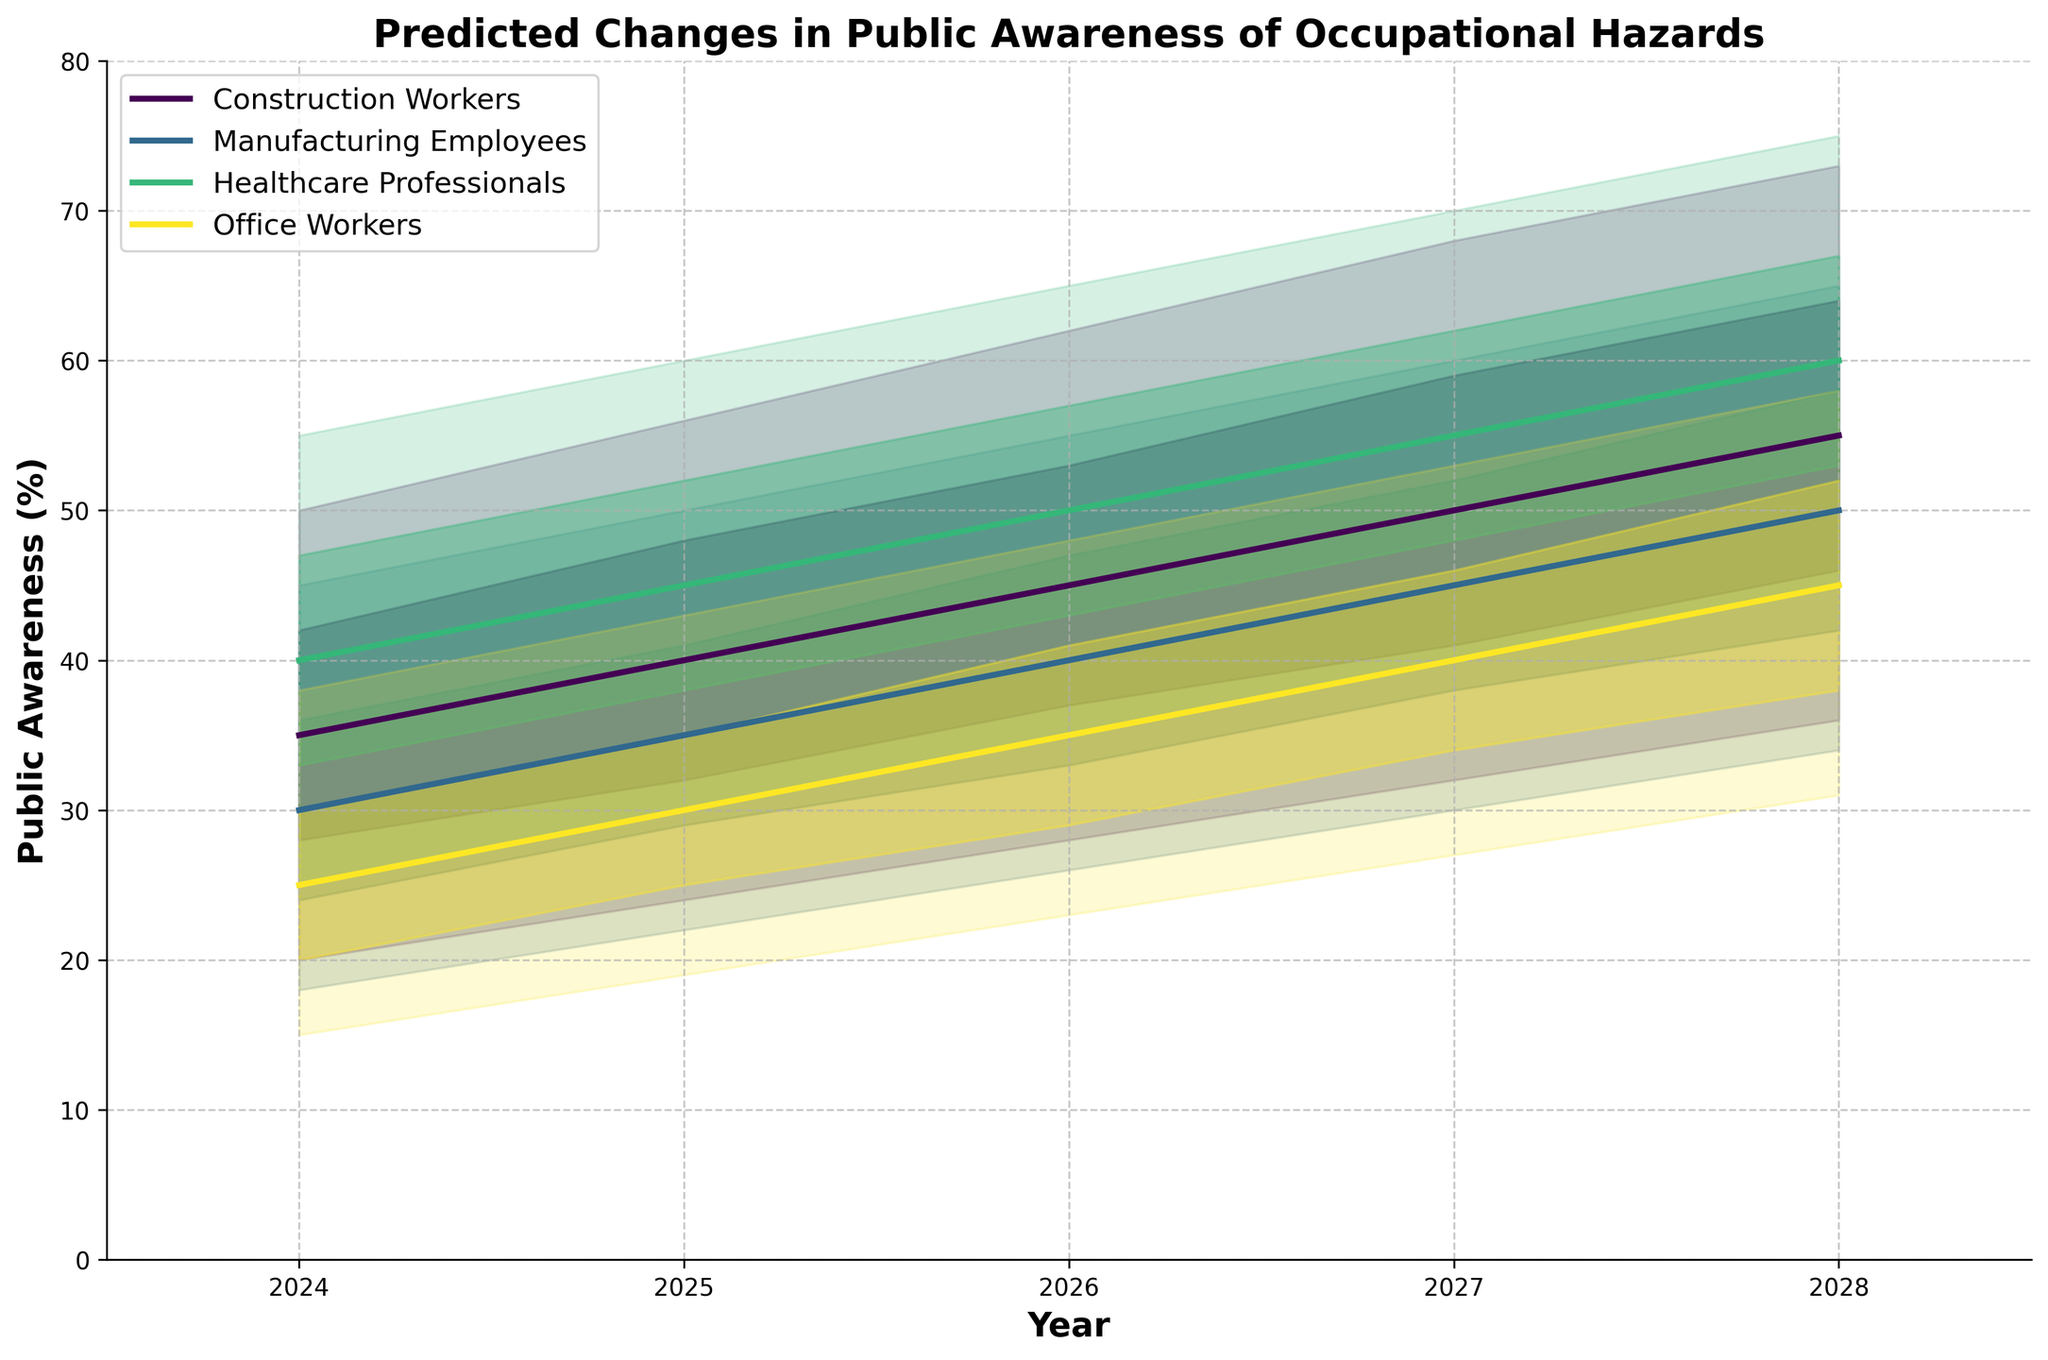What is the title of the chart? The title is located at the top of the chart, it reads "Predicted Changes in Public Awareness of Occupational Hazards."
Answer: Predicted Changes in Public Awareness of Occupational Hazards Which category has the highest median prediction for the year 2028? By checking the median line for each category in the year 2028, the category with the highest value is "Healthcare Professionals" with a median of 60%.
Answer: Healthcare Professionals What is the range for the 'Upper 75%' value for Construction Workers from 2024 to 2028? The 'Upper 75%' values for Construction Workers from 2024 to 2028 are 42, 48, 53, 59, and 64, respectively.
Answer: 42 to 64 How does the median prediction for Office Workers change from 2024 to 2028? The median predictions for Office Workers from 2024 to 2028 are 25%, 30%, 35%, 40%, and 45%, respectively, indicating a steady increase.
Answer: Steady increase Compare the upper 90% prediction for Manufacturing Employees and Healthcare Professionals in 2025. Which is higher and by how much? In 2025, the upper 90% prediction for Manufacturing Employees is 50% while for Healthcare Professionals it is 60%. The difference is 10%.
Answer: Healthcare Professionals by 10% What's the lower 10% value for Office Workers in 2026? The lower 10% value is found at the bottom edge of the lightest shaded region for Office Workers in 2026, which is 23%.
Answer: 23% Which category shows the greatest range in the Upper 90% prediction in 2028 compared to 2024? The Upper 90% prediction range for each category can be found by subtracting the 2024 value from the 2028 value. The biggest change is noted for Construction Workers where the range changes from 50% in 2024 to 73% in 2028, thus 23%.
Answer: Construction Workers What's the average median prediction for Healthcare Professionals over the years shown? The median predictions for Healthcare Professionals from 2024 to 2028 are 40, 45, 50, 55, and 60. The average is (40 + 45 + 50 + 55 + 60) / 5 = 50%.
Answer: 50% What trend can you observe for the overall predicted public awareness for all categories from 2024 to 2028? By looking at the median lines for all categories, there is an overall increasing trend in public awareness predictions from 2024 to 2028.
Answer: Increasing trend 